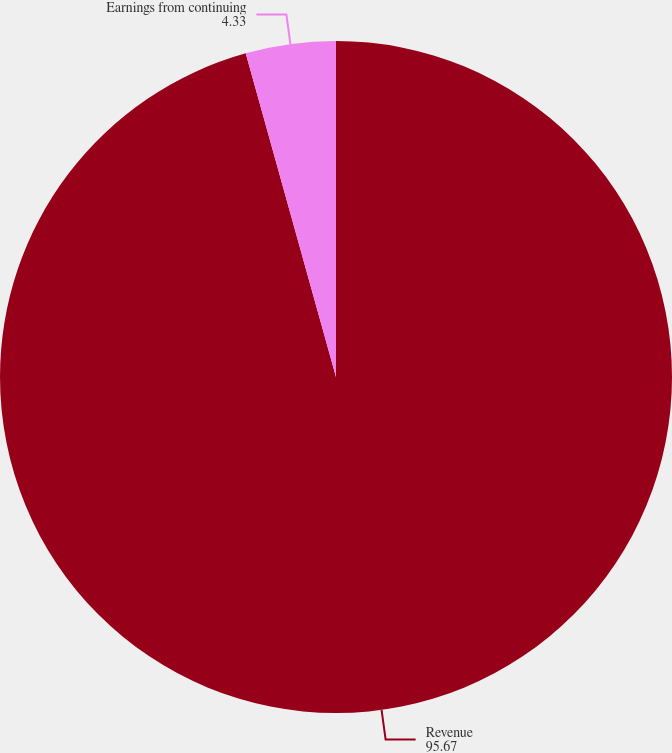<chart> <loc_0><loc_0><loc_500><loc_500><pie_chart><fcel>Revenue<fcel>Earnings from continuing<nl><fcel>95.67%<fcel>4.33%<nl></chart> 